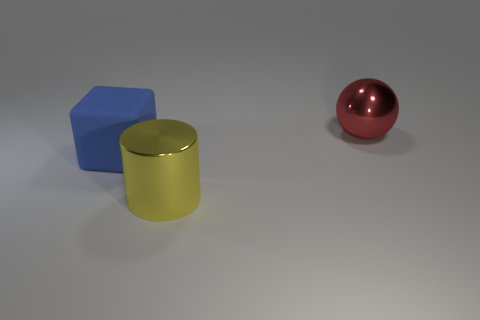Add 1 green rubber balls. How many objects exist? 4 Subtract all cylinders. How many objects are left? 2 Add 1 large green rubber cylinders. How many large green rubber cylinders exist? 1 Subtract 0 gray cubes. How many objects are left? 3 Subtract all tiny green metal spheres. Subtract all red shiny objects. How many objects are left? 2 Add 3 big red things. How many big red things are left? 4 